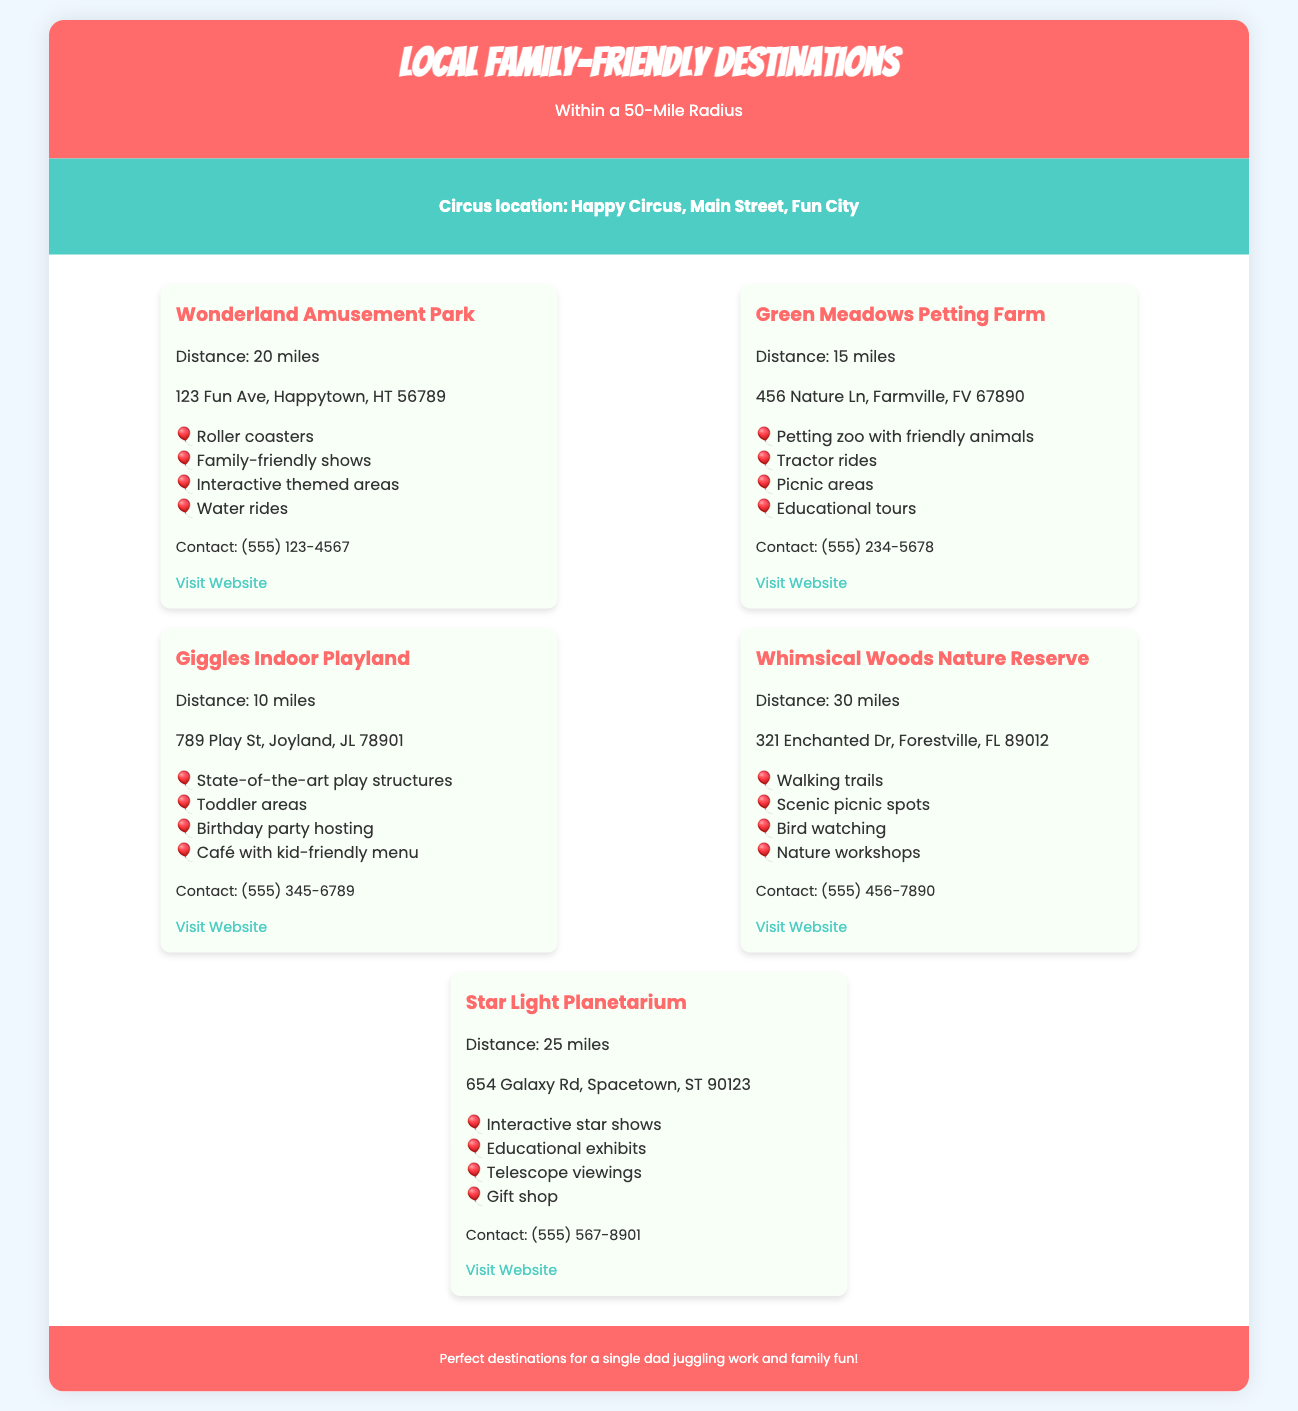What is the distance to Wonderland Amusement Park? The distance to Wonderland Amusement Park is explicitly stated in the document as 20 miles.
Answer: 20 miles What petting farm is located 15 miles away? The document names Green Meadows Petting Farm as the petting farm that is 15 miles away.
Answer: Green Meadows Petting Farm Which destination has interactive star shows? The Star Light Planetarium is the destination that offers interactive star shows according to the highlights in the document.
Answer: Star Light Planetarium How many destinations listed are within 20 miles? The document lists Giggles Indoor Playland, Green Meadows Petting Farm, and Wonderland Amusement Park, totaling three destinations within 20 miles.
Answer: 3 What type of rides does Wonderland Amusement Park offer? The highlights section mentions roller coasters, indicating the types of rides available at Wonderland Amusement Park.
Answer: Roller coasters What is the common feature of all the destinations? Each destination is presented as family-friendly, which is a common theme throughout the document.
Answer: Family-friendly What is the contact number for Giggles Indoor Playland? The contact number provided in the document for Giggles Indoor Playland is clearly listed as (555) 345-6789.
Answer: (555) 345-6789 How many miles is Whimsical Woods Nature Reserve from the circus? According to the document, Whimsical Woods Nature Reserve is 30 miles from the circus.
Answer: 30 miles What unique feature does the Green Meadows Petting Farm offer? The document highlights that Green Meadows Petting Farm offers a petting zoo with friendly animals, making it unique.
Answer: Petting zoo with friendly animals 